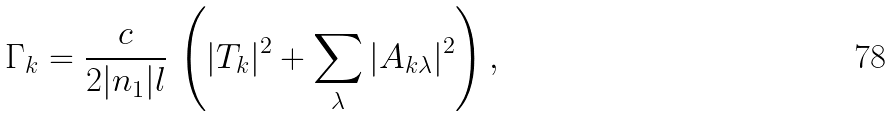<formula> <loc_0><loc_0><loc_500><loc_500>\Gamma _ { k } = \frac { c } { 2 | n _ { 1 } | l } \, \left ( | T _ { k } | ^ { 2 } + \sum _ { \lambda } | A _ { k \lambda } | ^ { 2 } \right ) ,</formula> 